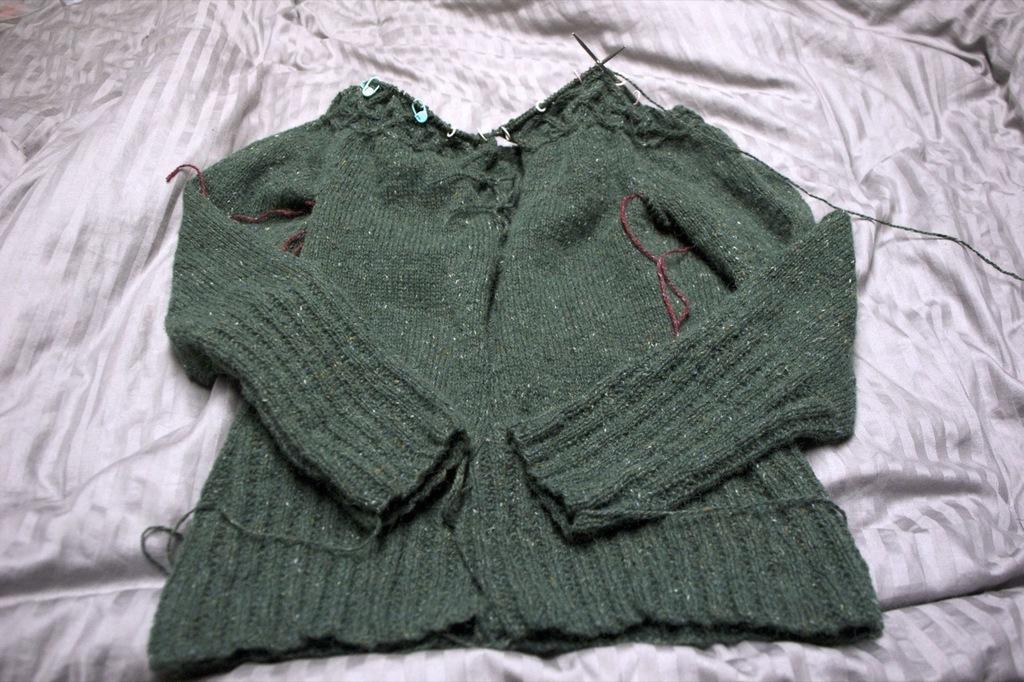Could you give a brief overview of what you see in this image? In this image, we can see a sweater on the white color blanket. 